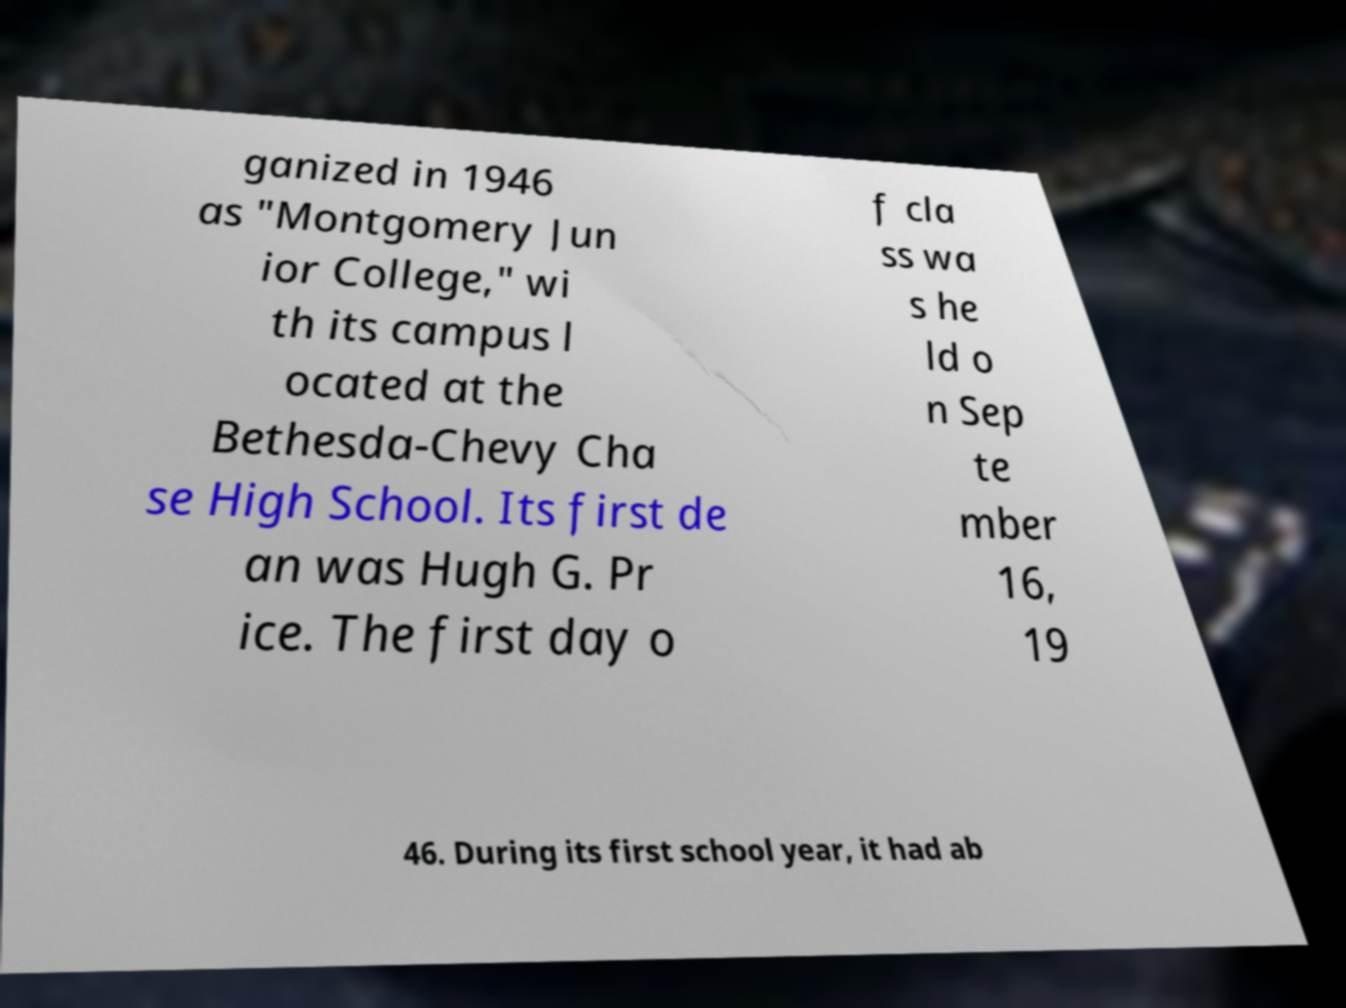Could you extract and type out the text from this image? ganized in 1946 as "Montgomery Jun ior College," wi th its campus l ocated at the Bethesda-Chevy Cha se High School. Its first de an was Hugh G. Pr ice. The first day o f cla ss wa s he ld o n Sep te mber 16, 19 46. During its first school year, it had ab 